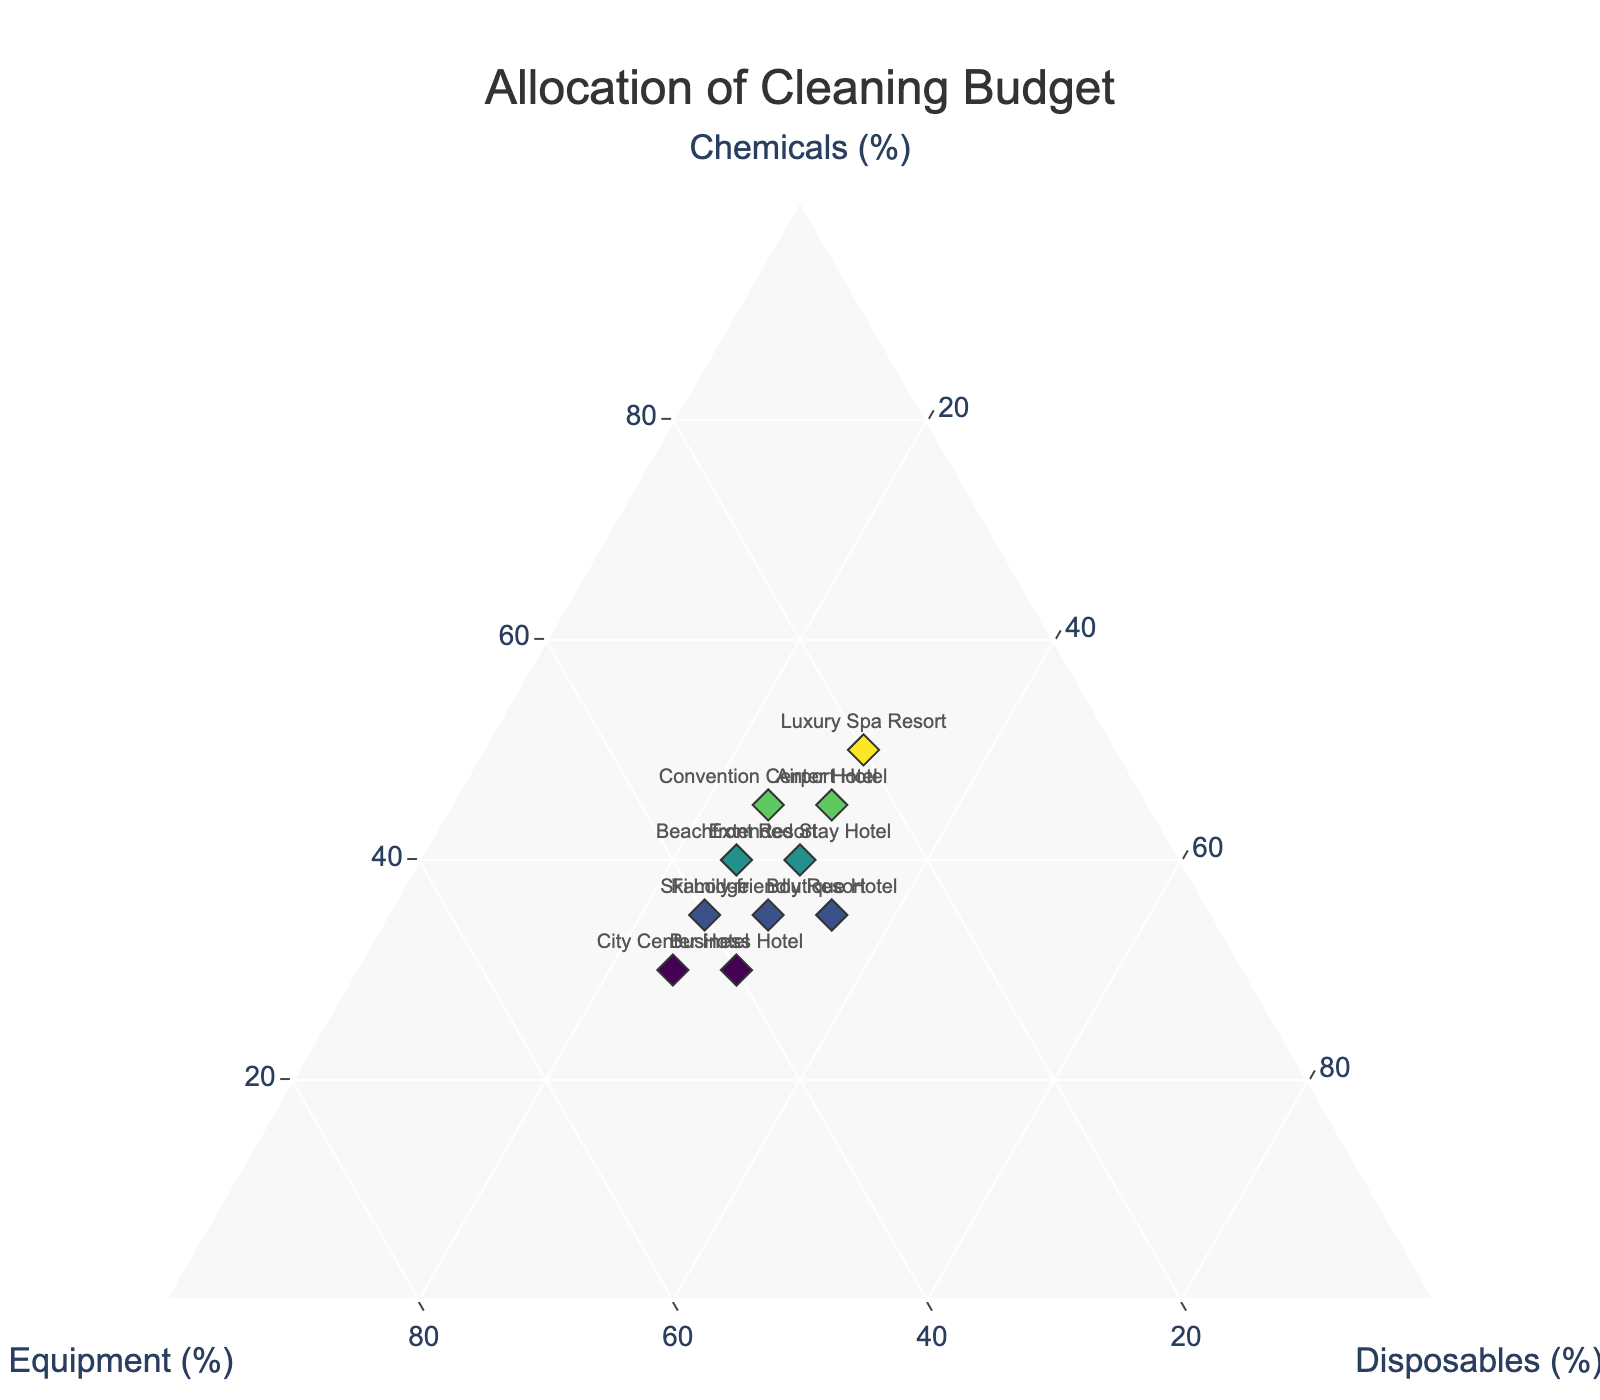What is the highest allocation percentage for "Chemicals"? To find the highest percentage allocation for "Chemicals," look for the data point with the maximum value on the 'Chemicals (%)' axis. The "Luxury Spa Resort" has the highest percentage with 50%.
Answer: 50% Which hotel allocates the least budget to "Equipment"? Look for the data point with the lowest value on the 'Equipment (%)' axis. The "Luxury Spa Resort" has the lowest allocation at 20%.
Answer: Luxury Spa Resort What is the average allocation percentage for "Disposables" across all hotels? Sum all the "Disposables" percentages and divide by the total number of data points. The sum is 25 + 25 + 35 + 30 + 30 + 30 + 30 + 30 + 25 + 25 = 285. There are 10 data points, so the average is 285 / 10 = 28.5%.
Answer: 28.5% Do any two hotels have the same allocation percentages for "Disposables"? Check if any "Disposables" percentages match across hotels. Both "City Center Hotel" and "Ski Lodge" allocate 25% to Disposables.
Answer: Yes, City Center Hotel and Ski Lodge Which hotel spends an equal budget percentage on "Chemicals" and "Equipment"? Check the hotels where the percentages for "Chemicals" and "Equipment" are the same. The "Beachfront Resort" and "Family-friendly Resort" both allocate 35% to "Chemicals" and 35% to "Equipment."
Answer: Beachfront Resort and Family-friendly Resort Which hotel dedicates the largest portion of its budget to a single category, and what is that category? Compare the highest single category percentage for each hotel. "Luxury Spa Resort" allocates the largest portion, 50%, to "Chemicals."
Answer: Luxury Spa Resort, Chemicals What is the sum of allocation percentages for "Chemicals" for "Beachfront Resort" and "Airport Hotel"? Add the "Chemicals" percentages for "Beachfront Resort" (40%) and "Airport Hotel" (45%). 40% + 45% = 85%.
Answer: 85% Which hotel has the closest allocation percentages for all three categories? Look for a data point where the percentages for all three categories are most nearly equal. The "Boutique Hotel" allocates 35% to "Chemicals," 30% to "Equipment," and 35% to "Disposables," which are quite balanced.
Answer: Boutique Hotel What is the difference in the allocation for "Disposables" between "City Center Hotel" and "Boutique Hotel"? Subtract the percentage allocation of "Disposables" for "City Center Hotel" (25%) from "Boutique Hotel" (35%). 35% - 25% = 10%.
Answer: 10% 